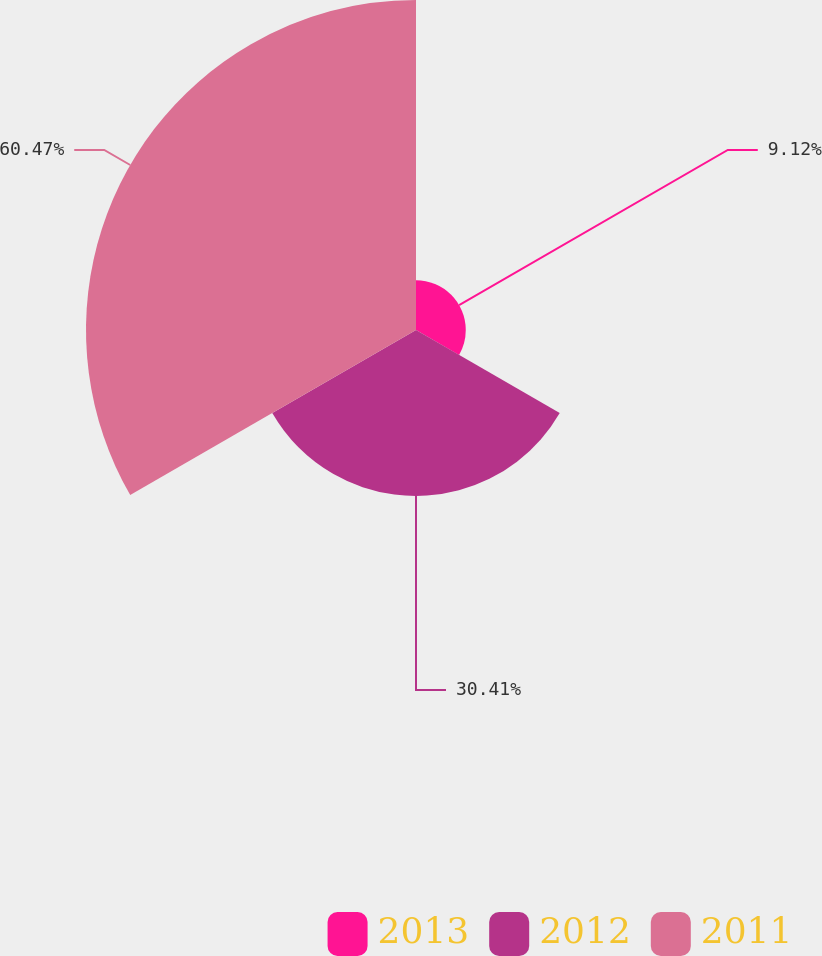Convert chart. <chart><loc_0><loc_0><loc_500><loc_500><pie_chart><fcel>2013<fcel>2012<fcel>2011<nl><fcel>9.12%<fcel>30.41%<fcel>60.47%<nl></chart> 